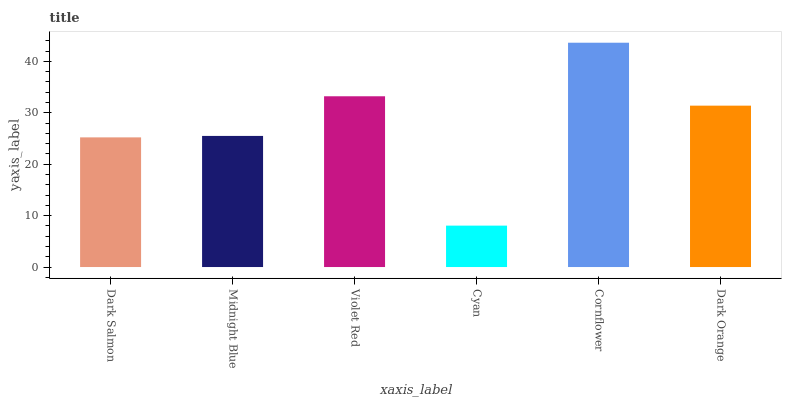Is Cyan the minimum?
Answer yes or no. Yes. Is Cornflower the maximum?
Answer yes or no. Yes. Is Midnight Blue the minimum?
Answer yes or no. No. Is Midnight Blue the maximum?
Answer yes or no. No. Is Midnight Blue greater than Dark Salmon?
Answer yes or no. Yes. Is Dark Salmon less than Midnight Blue?
Answer yes or no. Yes. Is Dark Salmon greater than Midnight Blue?
Answer yes or no. No. Is Midnight Blue less than Dark Salmon?
Answer yes or no. No. Is Dark Orange the high median?
Answer yes or no. Yes. Is Midnight Blue the low median?
Answer yes or no. Yes. Is Cornflower the high median?
Answer yes or no. No. Is Cornflower the low median?
Answer yes or no. No. 